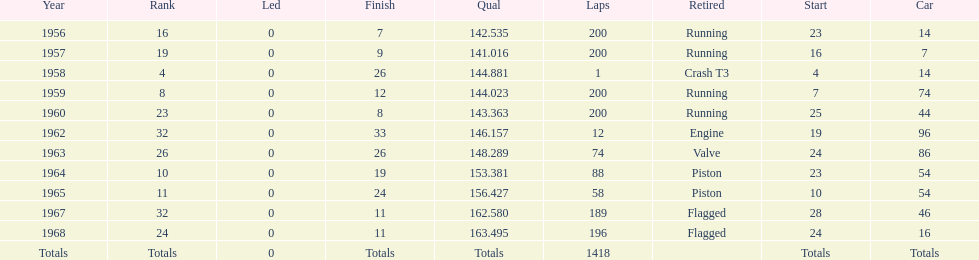How many times was bob veith ranked higher than 10 at an indy 500? 2. 